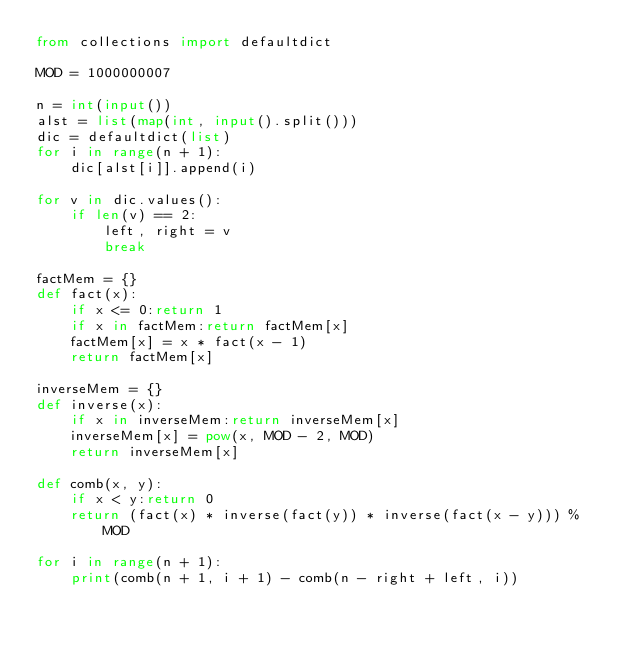<code> <loc_0><loc_0><loc_500><loc_500><_Python_>from collections import defaultdict

MOD = 1000000007

n = int(input())
alst = list(map(int, input().split()))
dic = defaultdict(list)
for i in range(n + 1):
    dic[alst[i]].append(i)

for v in dic.values():
    if len(v) == 2:
        left, right = v
        break

factMem = {}
def fact(x):
    if x <= 0:return 1
    if x in factMem:return factMem[x]
    factMem[x] = x * fact(x - 1)
    return factMem[x]

inverseMem = {}
def inverse(x):
    if x in inverseMem:return inverseMem[x]
    inverseMem[x] = pow(x, MOD - 2, MOD)
    return inverseMem[x]

def comb(x, y):
    if x < y:return 0
    return (fact(x) * inverse(fact(y)) * inverse(fact(x - y))) % MOD

for i in range(n + 1):
    print(comb(n + 1, i + 1) - comb(n - right + left, i))
</code> 